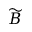Convert formula to latex. <formula><loc_0><loc_0><loc_500><loc_500>\widetilde { B }</formula> 